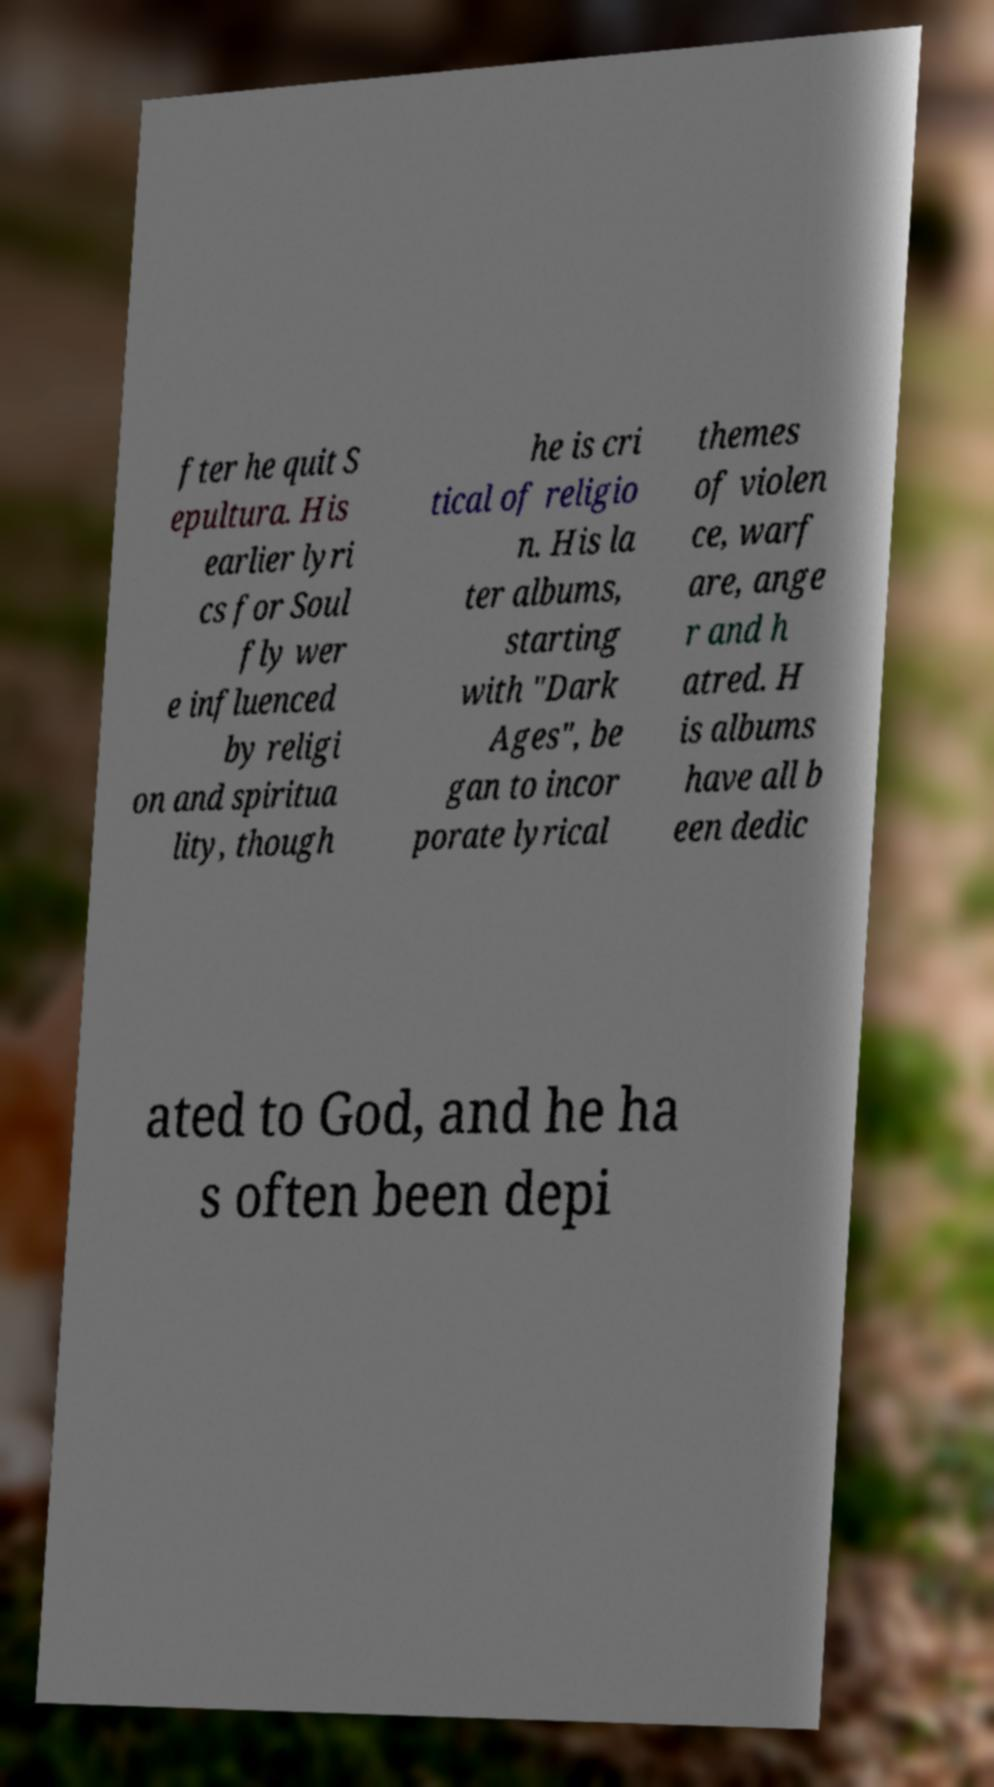Can you read and provide the text displayed in the image?This photo seems to have some interesting text. Can you extract and type it out for me? fter he quit S epultura. His earlier lyri cs for Soul fly wer e influenced by religi on and spiritua lity, though he is cri tical of religio n. His la ter albums, starting with "Dark Ages", be gan to incor porate lyrical themes of violen ce, warf are, ange r and h atred. H is albums have all b een dedic ated to God, and he ha s often been depi 